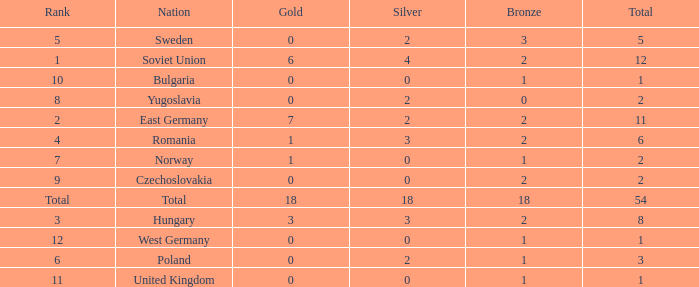What's the highest total of Romania when the bronze was less than 2? None. Would you mind parsing the complete table? {'header': ['Rank', 'Nation', 'Gold', 'Silver', 'Bronze', 'Total'], 'rows': [['5', 'Sweden', '0', '2', '3', '5'], ['1', 'Soviet Union', '6', '4', '2', '12'], ['10', 'Bulgaria', '0', '0', '1', '1'], ['8', 'Yugoslavia', '0', '2', '0', '2'], ['2', 'East Germany', '7', '2', '2', '11'], ['4', 'Romania', '1', '3', '2', '6'], ['7', 'Norway', '1', '0', '1', '2'], ['9', 'Czechoslovakia', '0', '0', '2', '2'], ['Total', 'Total', '18', '18', '18', '54'], ['3', 'Hungary', '3', '3', '2', '8'], ['12', 'West Germany', '0', '0', '1', '1'], ['6', 'Poland', '0', '2', '1', '3'], ['11', 'United Kingdom', '0', '0', '1', '1']]} 